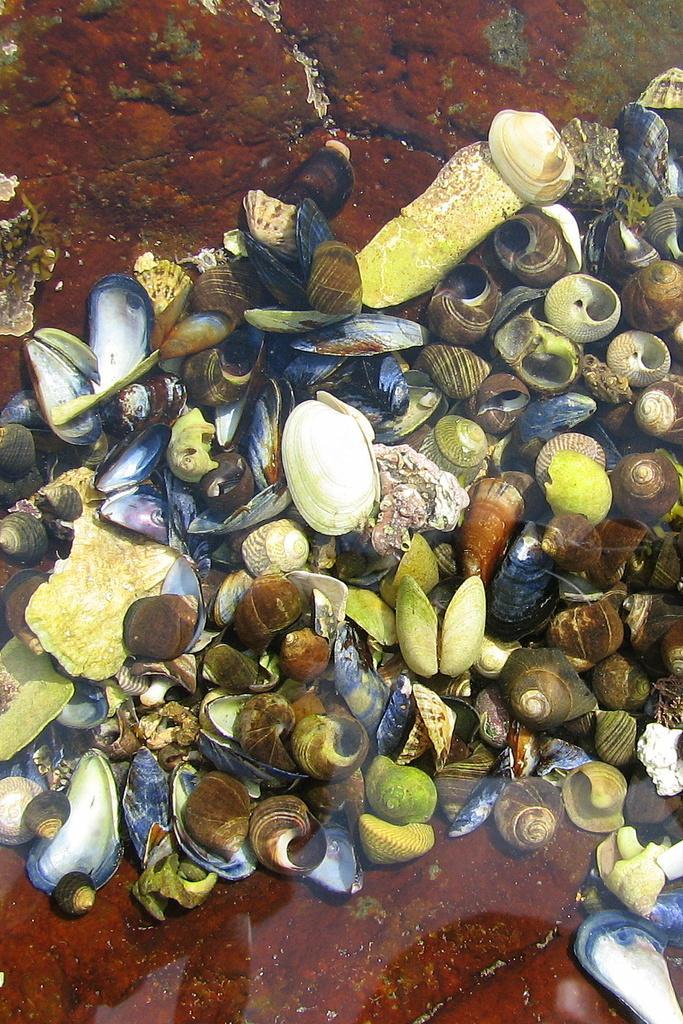Describe this image in one or two sentences. In this picture there are seashells in the center of the image. 